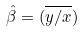<formula> <loc_0><loc_0><loc_500><loc_500>\hat { \beta } = ( \overline { y / x } )</formula> 